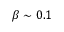<formula> <loc_0><loc_0><loc_500><loc_500>\beta \sim 0 . 1</formula> 